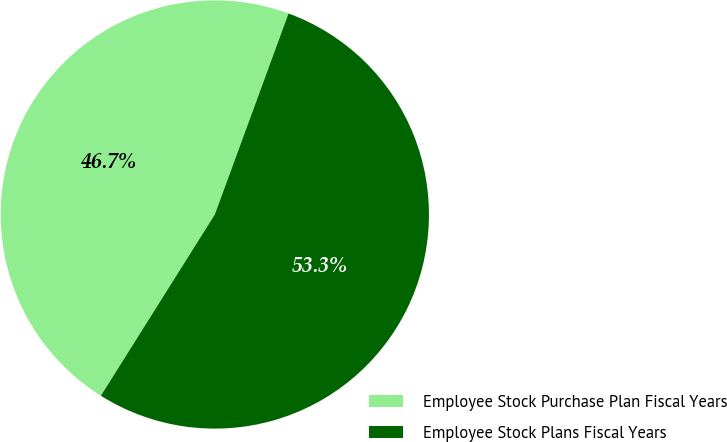Convert chart to OTSL. <chart><loc_0><loc_0><loc_500><loc_500><pie_chart><fcel>Employee Stock Purchase Plan Fiscal Years<fcel>Employee Stock Plans Fiscal Years<nl><fcel>46.66%<fcel>53.34%<nl></chart> 